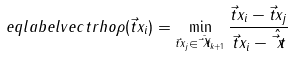<formula> <loc_0><loc_0><loc_500><loc_500>\ e q l a b e l { v e c t r h o } \rho ( \vec { t } { x } _ { i } ) = \min _ { \vec { t } { x } _ { j } \in \bar { \vec { t } { X } } _ { k + 1 } } \frac { \| \vec { t } { x } _ { i } - \vec { t } { x } _ { j } \| } { \| \vec { t } { x } _ { i } - \hat { \vec { t } { x } } \| }</formula> 